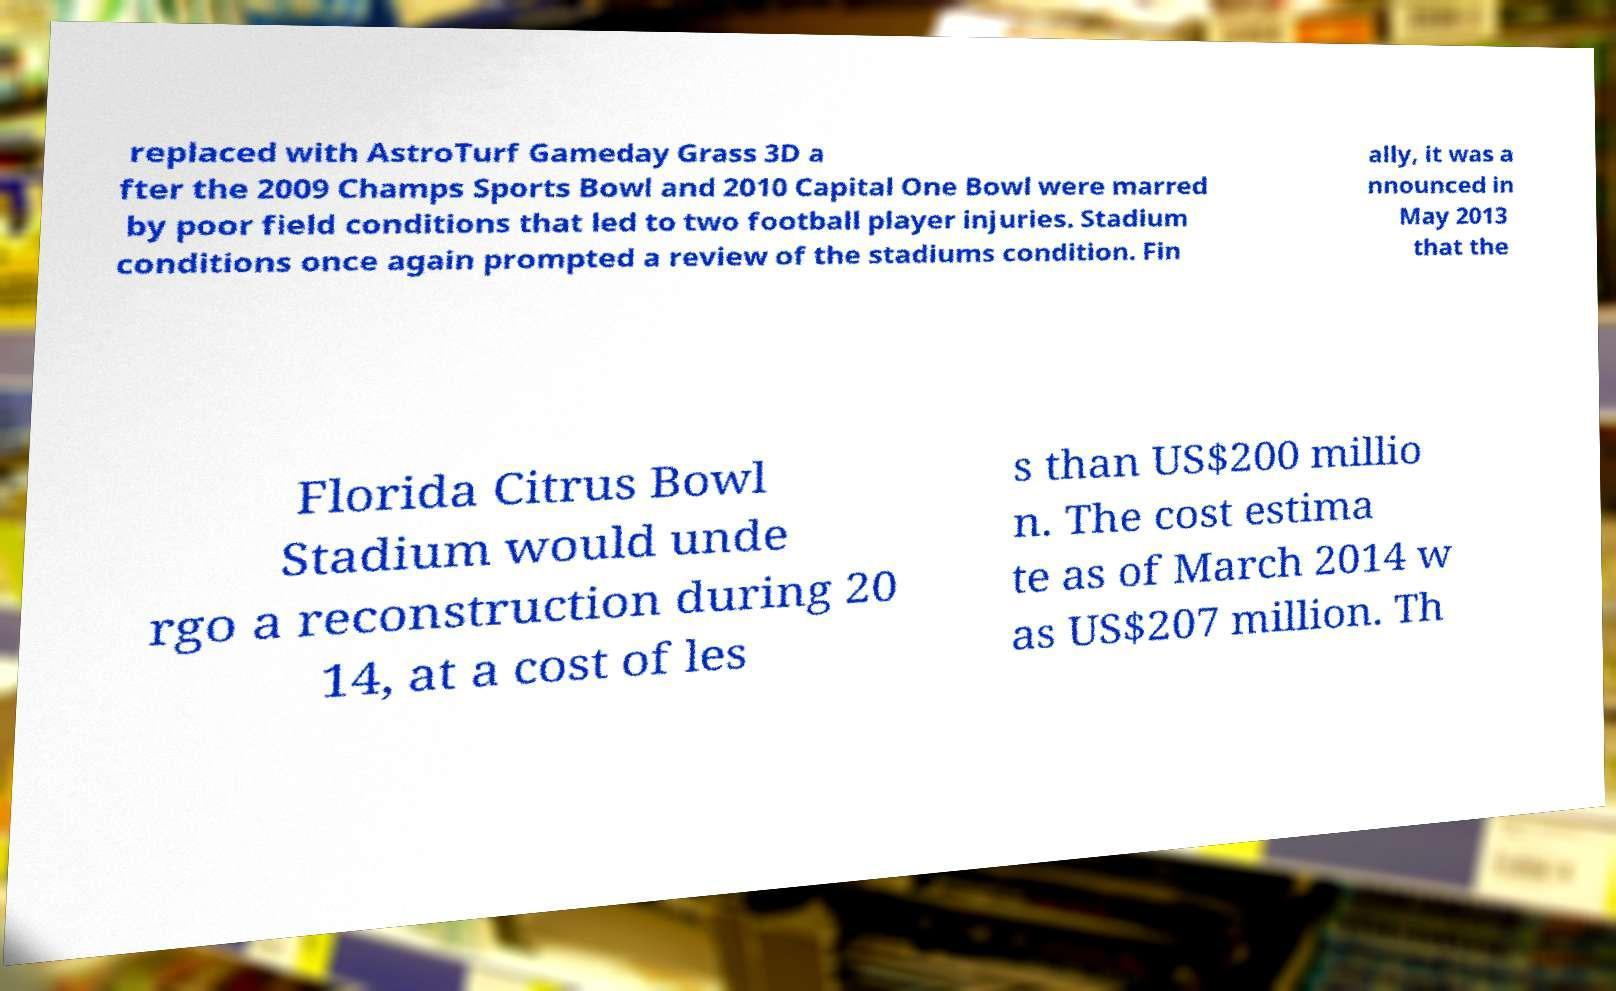Can you accurately transcribe the text from the provided image for me? replaced with AstroTurf Gameday Grass 3D a fter the 2009 Champs Sports Bowl and 2010 Capital One Bowl were marred by poor field conditions that led to two football player injuries. Stadium conditions once again prompted a review of the stadiums condition. Fin ally, it was a nnounced in May 2013 that the Florida Citrus Bowl Stadium would unde rgo a reconstruction during 20 14, at a cost of les s than US$200 millio n. The cost estima te as of March 2014 w as US$207 million. Th 